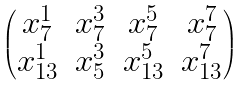Convert formula to latex. <formula><loc_0><loc_0><loc_500><loc_500>\begin{pmatrix} x _ { 7 } ^ { 1 } & x _ { 7 } ^ { 3 } & x _ { 7 } ^ { 5 } & x _ { 7 } ^ { 7 } \\ x _ { 1 3 } ^ { 1 } & x _ { 5 } ^ { 3 } & x _ { 1 3 } ^ { 5 } & x _ { 1 3 } ^ { 7 } \end{pmatrix}</formula> 